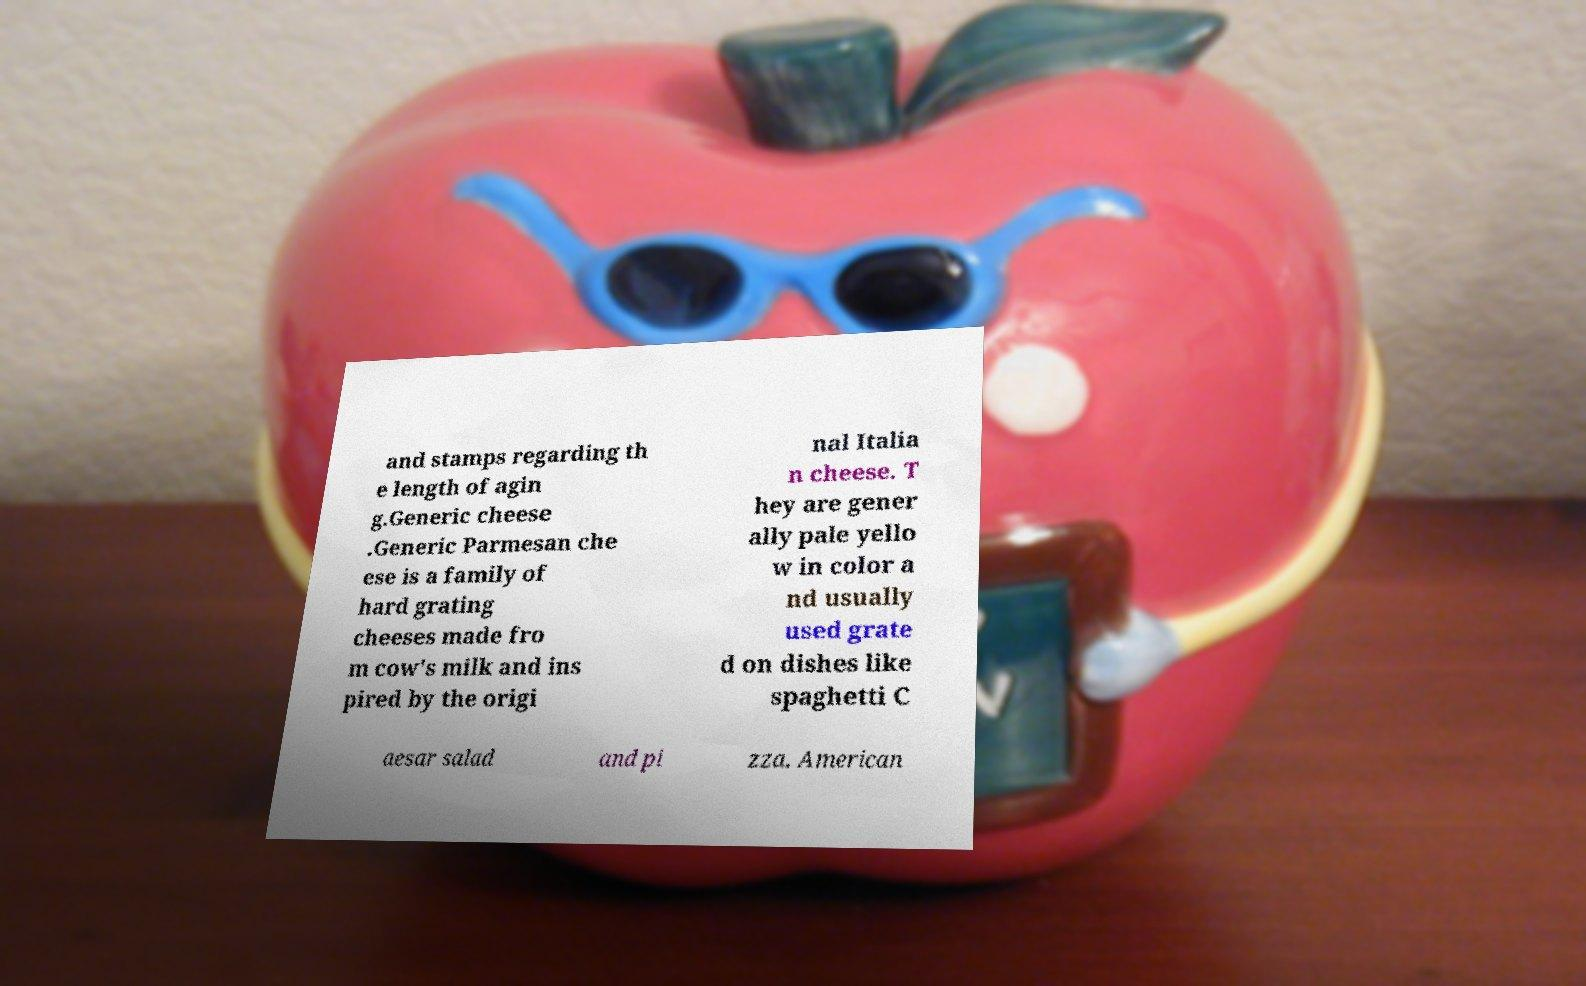Please identify and transcribe the text found in this image. and stamps regarding th e length of agin g.Generic cheese .Generic Parmesan che ese is a family of hard grating cheeses made fro m cow's milk and ins pired by the origi nal Italia n cheese. T hey are gener ally pale yello w in color a nd usually used grate d on dishes like spaghetti C aesar salad and pi zza. American 